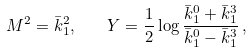Convert formula to latex. <formula><loc_0><loc_0><loc_500><loc_500>M ^ { 2 } = \bar { k } _ { 1 } ^ { 2 } , \quad Y = \frac { 1 } { 2 } \log \frac { \bar { k } _ { 1 } ^ { 0 } + \bar { k } _ { 1 } ^ { 3 } } { \bar { k } _ { 1 } ^ { 0 } - \bar { k } _ { 1 } ^ { 3 } } \, ,</formula> 